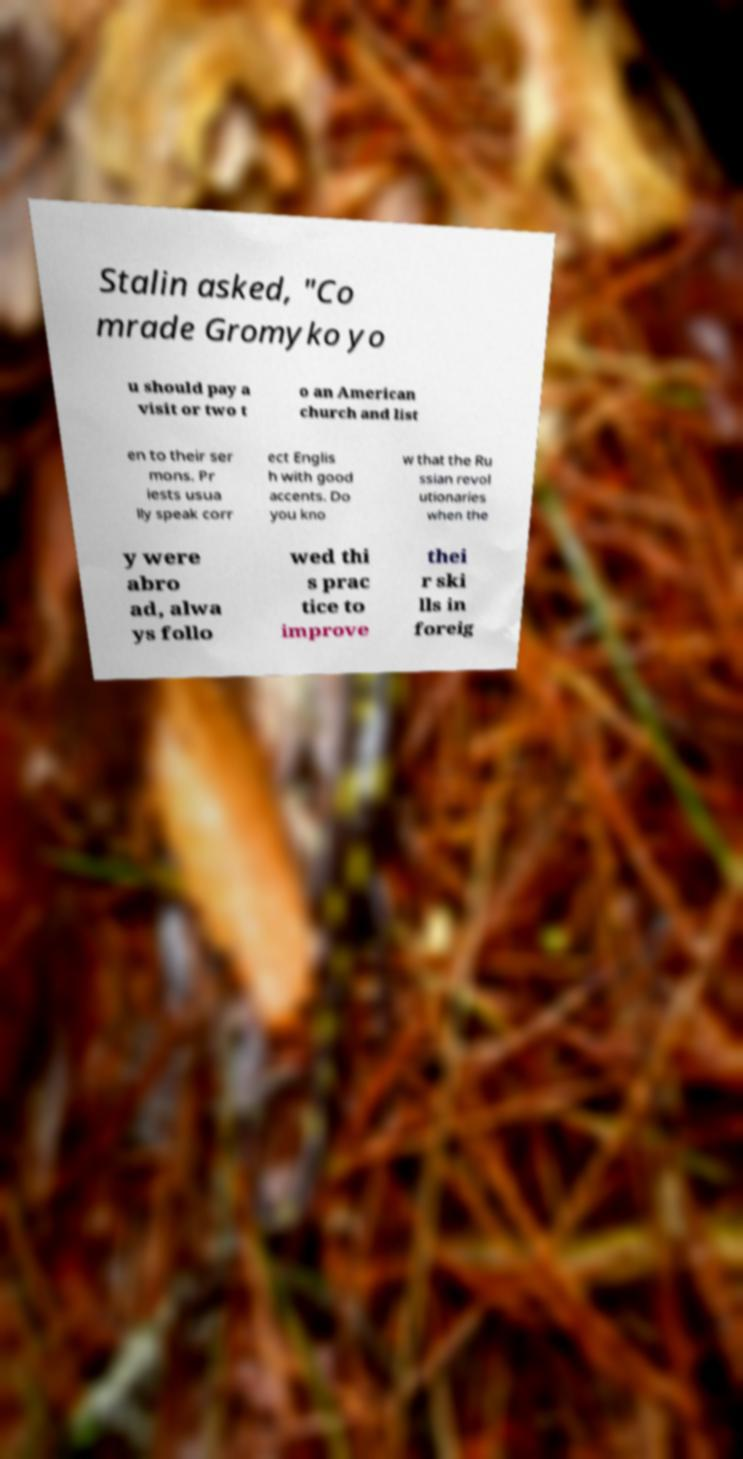Please read and relay the text visible in this image. What does it say? Stalin asked, "Co mrade Gromyko yo u should pay a visit or two t o an American church and list en to their ser mons. Pr iests usua lly speak corr ect Englis h with good accents. Do you kno w that the Ru ssian revol utionaries when the y were abro ad, alwa ys follo wed thi s prac tice to improve thei r ski lls in foreig 